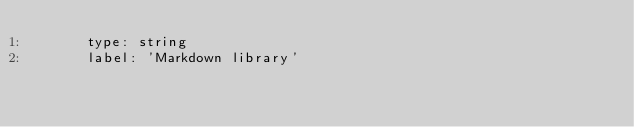Convert code to text. <code><loc_0><loc_0><loc_500><loc_500><_YAML_>      type: string
      label: 'Markdown library'
</code> 